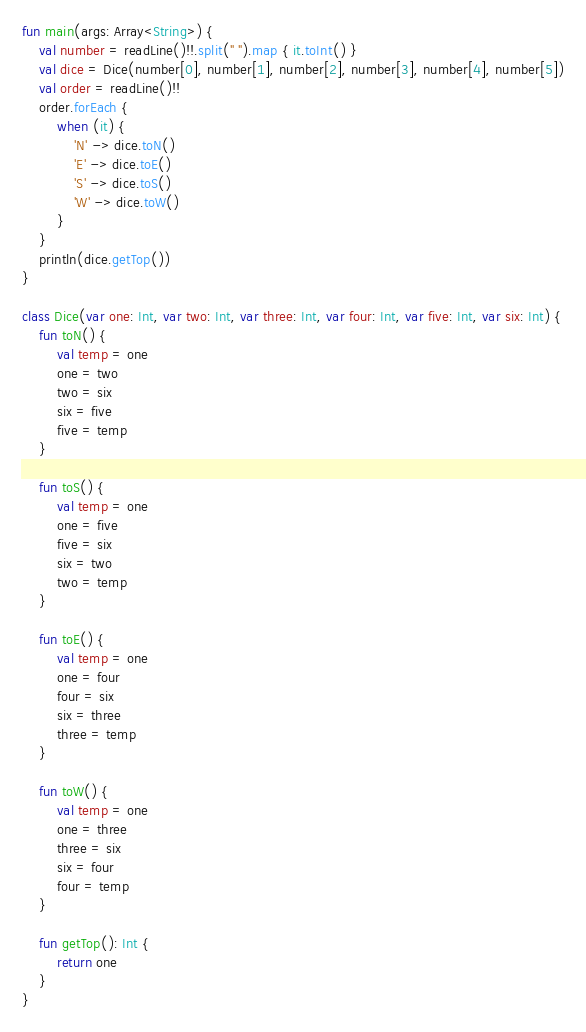<code> <loc_0><loc_0><loc_500><loc_500><_Kotlin_>fun main(args: Array<String>) {
    val number = readLine()!!.split(" ").map { it.toInt() }
    val dice = Dice(number[0], number[1], number[2], number[3], number[4], number[5])
    val order = readLine()!!
    order.forEach {
        when (it) {
            'N' -> dice.toN()
            'E' -> dice.toE()
            'S' -> dice.toS()
            'W' -> dice.toW()
        }
    }
    println(dice.getTop())
}

class Dice(var one: Int, var two: Int, var three: Int, var four: Int, var five: Int, var six: Int) {
    fun toN() {
        val temp = one
        one = two
        two = six
        six = five
        five = temp
    }

    fun toS() {
        val temp = one
        one = five
        five = six
        six = two
        two = temp
    }

    fun toE() {
        val temp = one
        one = four
        four = six
        six = three
        three = temp
    }

    fun toW() {
        val temp = one
        one = three
        three = six
        six = four
        four = temp
    }

    fun getTop(): Int {
        return one
    }
}
</code> 